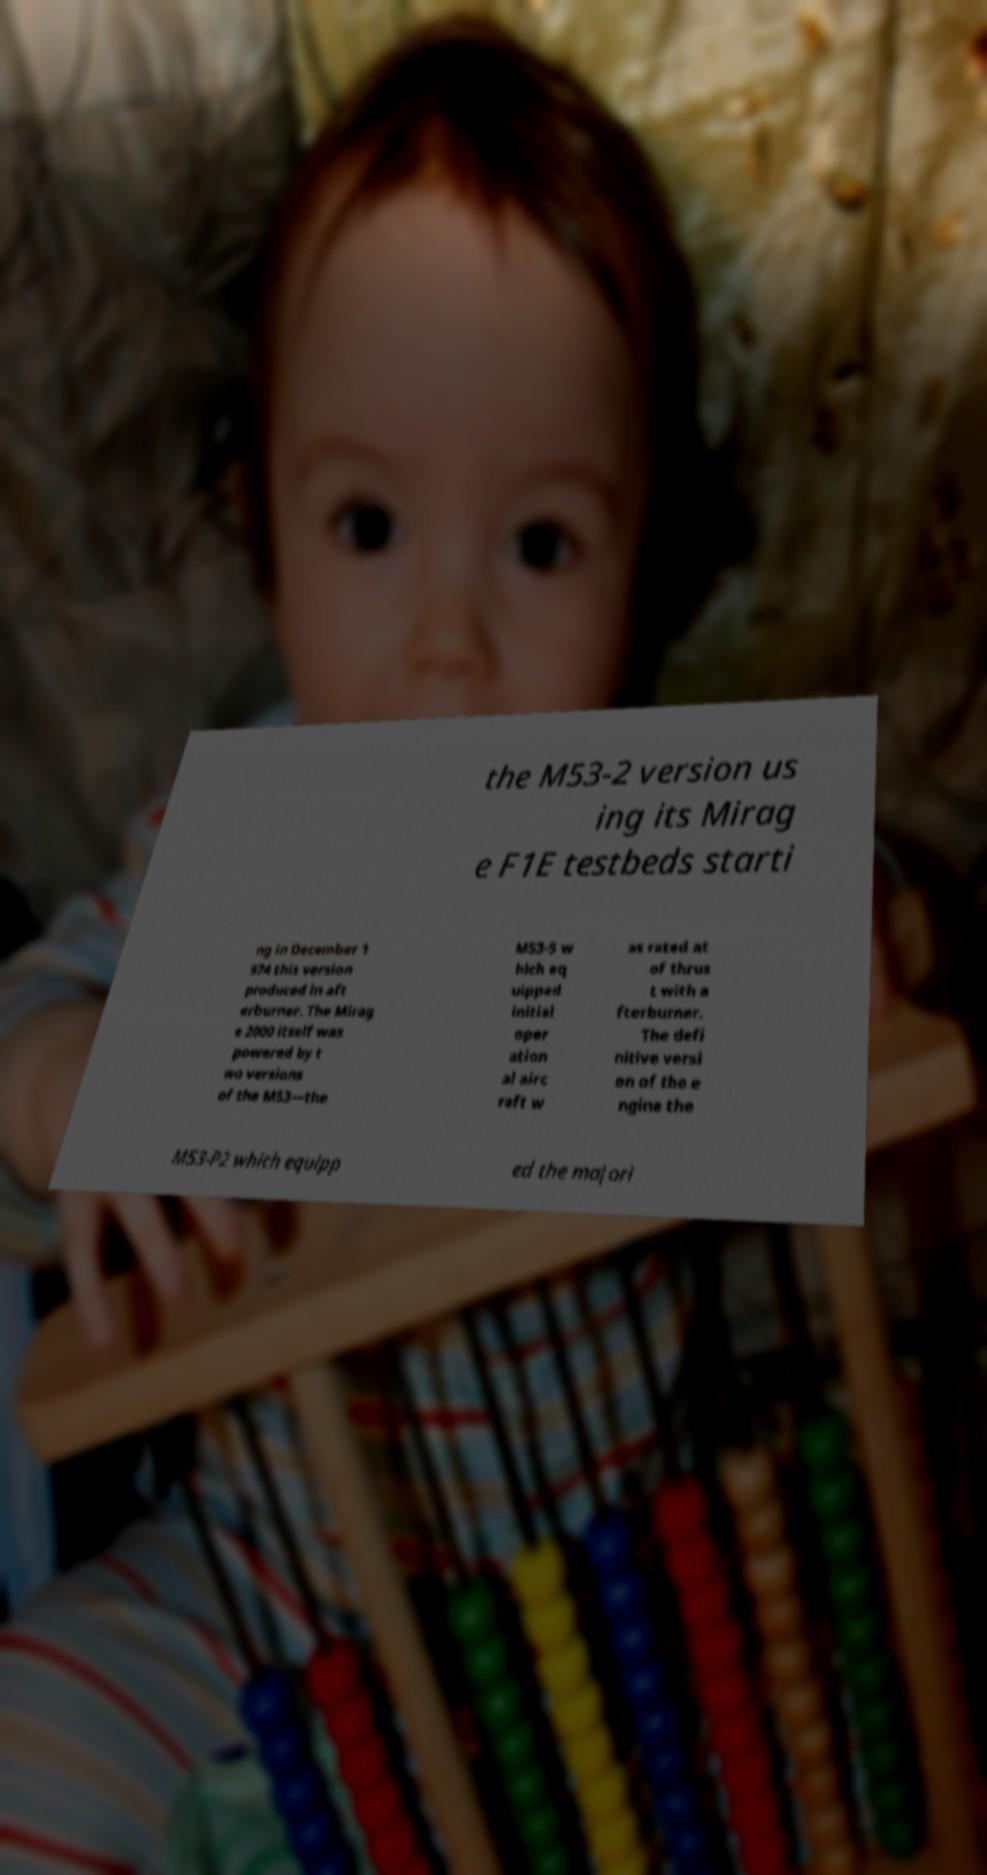What messages or text are displayed in this image? I need them in a readable, typed format. the M53-2 version us ing its Mirag e F1E testbeds starti ng in December 1 974 this version produced in aft erburner. The Mirag e 2000 itself was powered by t wo versions of the M53—the M53-5 w hich eq uipped initial oper ation al airc raft w as rated at of thrus t with a fterburner. The defi nitive versi on of the e ngine the M53-P2 which equipp ed the majori 